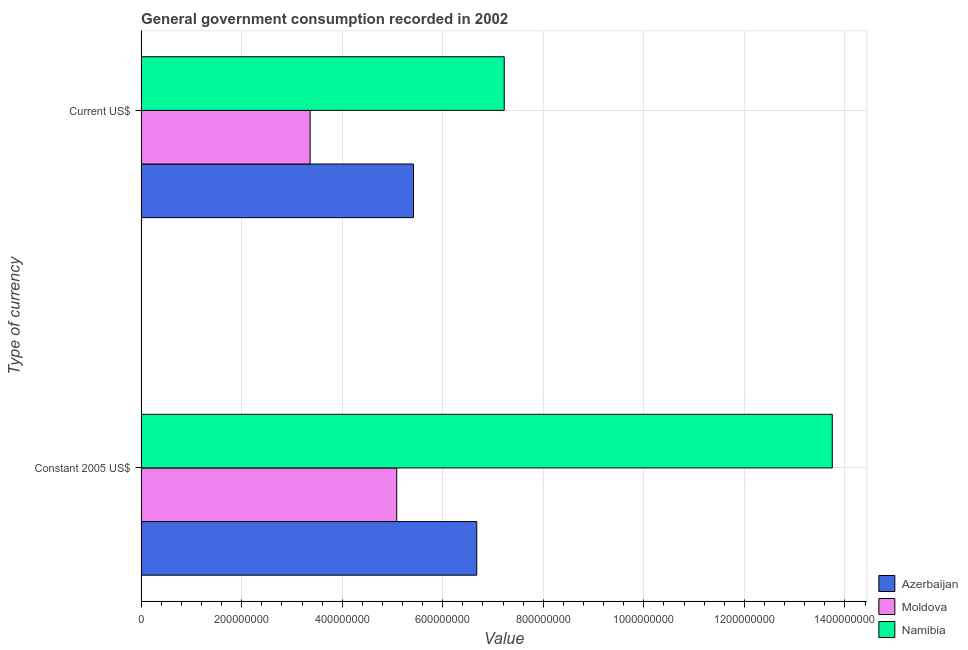How many different coloured bars are there?
Give a very brief answer. 3. Are the number of bars per tick equal to the number of legend labels?
Make the answer very short. Yes. Are the number of bars on each tick of the Y-axis equal?
Ensure brevity in your answer.  Yes. What is the label of the 1st group of bars from the top?
Offer a terse response. Current US$. What is the value consumed in constant 2005 us$ in Moldova?
Provide a succinct answer. 5.08e+08. Across all countries, what is the maximum value consumed in current us$?
Provide a short and direct response. 7.22e+08. Across all countries, what is the minimum value consumed in current us$?
Make the answer very short. 3.36e+08. In which country was the value consumed in constant 2005 us$ maximum?
Your answer should be very brief. Namibia. In which country was the value consumed in current us$ minimum?
Give a very brief answer. Moldova. What is the total value consumed in current us$ in the graph?
Your answer should be compact. 1.60e+09. What is the difference between the value consumed in constant 2005 us$ in Moldova and that in Namibia?
Make the answer very short. -8.66e+08. What is the difference between the value consumed in constant 2005 us$ in Moldova and the value consumed in current us$ in Namibia?
Offer a very short reply. -2.14e+08. What is the average value consumed in constant 2005 us$ per country?
Your response must be concise. 8.50e+08. What is the difference between the value consumed in constant 2005 us$ and value consumed in current us$ in Azerbaijan?
Your answer should be compact. 1.26e+08. What is the ratio of the value consumed in current us$ in Namibia to that in Moldova?
Offer a terse response. 2.15. In how many countries, is the value consumed in current us$ greater than the average value consumed in current us$ taken over all countries?
Make the answer very short. 2. What does the 2nd bar from the top in Constant 2005 US$ represents?
Provide a short and direct response. Moldova. What does the 1st bar from the bottom in Current US$ represents?
Ensure brevity in your answer.  Azerbaijan. Are all the bars in the graph horizontal?
Keep it short and to the point. Yes. How many countries are there in the graph?
Offer a terse response. 3. Are the values on the major ticks of X-axis written in scientific E-notation?
Your response must be concise. No. Where does the legend appear in the graph?
Provide a short and direct response. Bottom right. How many legend labels are there?
Offer a terse response. 3. How are the legend labels stacked?
Provide a succinct answer. Vertical. What is the title of the graph?
Give a very brief answer. General government consumption recorded in 2002. What is the label or title of the X-axis?
Keep it short and to the point. Value. What is the label or title of the Y-axis?
Your answer should be compact. Type of currency. What is the Value in Azerbaijan in Constant 2005 US$?
Offer a terse response. 6.68e+08. What is the Value in Moldova in Constant 2005 US$?
Offer a very short reply. 5.08e+08. What is the Value in Namibia in Constant 2005 US$?
Ensure brevity in your answer.  1.37e+09. What is the Value in Azerbaijan in Current US$?
Provide a succinct answer. 5.42e+08. What is the Value in Moldova in Current US$?
Keep it short and to the point. 3.36e+08. What is the Value in Namibia in Current US$?
Make the answer very short. 7.22e+08. Across all Type of currency, what is the maximum Value in Azerbaijan?
Your response must be concise. 6.68e+08. Across all Type of currency, what is the maximum Value of Moldova?
Offer a terse response. 5.08e+08. Across all Type of currency, what is the maximum Value in Namibia?
Your answer should be very brief. 1.37e+09. Across all Type of currency, what is the minimum Value of Azerbaijan?
Keep it short and to the point. 5.42e+08. Across all Type of currency, what is the minimum Value in Moldova?
Give a very brief answer. 3.36e+08. Across all Type of currency, what is the minimum Value of Namibia?
Your answer should be compact. 7.22e+08. What is the total Value of Azerbaijan in the graph?
Offer a very short reply. 1.21e+09. What is the total Value in Moldova in the graph?
Your answer should be compact. 8.45e+08. What is the total Value in Namibia in the graph?
Your response must be concise. 2.10e+09. What is the difference between the Value of Azerbaijan in Constant 2005 US$ and that in Current US$?
Your response must be concise. 1.26e+08. What is the difference between the Value in Moldova in Constant 2005 US$ and that in Current US$?
Provide a succinct answer. 1.72e+08. What is the difference between the Value of Namibia in Constant 2005 US$ and that in Current US$?
Offer a terse response. 6.53e+08. What is the difference between the Value in Azerbaijan in Constant 2005 US$ and the Value in Moldova in Current US$?
Keep it short and to the point. 3.32e+08. What is the difference between the Value in Azerbaijan in Constant 2005 US$ and the Value in Namibia in Current US$?
Offer a very short reply. -5.46e+07. What is the difference between the Value of Moldova in Constant 2005 US$ and the Value of Namibia in Current US$?
Make the answer very short. -2.14e+08. What is the average Value in Azerbaijan per Type of currency?
Make the answer very short. 6.05e+08. What is the average Value in Moldova per Type of currency?
Your answer should be very brief. 4.22e+08. What is the average Value in Namibia per Type of currency?
Provide a succinct answer. 1.05e+09. What is the difference between the Value in Azerbaijan and Value in Moldova in Constant 2005 US$?
Provide a short and direct response. 1.59e+08. What is the difference between the Value in Azerbaijan and Value in Namibia in Constant 2005 US$?
Provide a succinct answer. -7.07e+08. What is the difference between the Value in Moldova and Value in Namibia in Constant 2005 US$?
Offer a terse response. -8.66e+08. What is the difference between the Value of Azerbaijan and Value of Moldova in Current US$?
Offer a terse response. 2.06e+08. What is the difference between the Value in Azerbaijan and Value in Namibia in Current US$?
Your answer should be compact. -1.81e+08. What is the difference between the Value in Moldova and Value in Namibia in Current US$?
Provide a succinct answer. -3.86e+08. What is the ratio of the Value in Azerbaijan in Constant 2005 US$ to that in Current US$?
Provide a short and direct response. 1.23. What is the ratio of the Value of Moldova in Constant 2005 US$ to that in Current US$?
Your answer should be compact. 1.51. What is the ratio of the Value of Namibia in Constant 2005 US$ to that in Current US$?
Your response must be concise. 1.9. What is the difference between the highest and the second highest Value of Azerbaijan?
Offer a terse response. 1.26e+08. What is the difference between the highest and the second highest Value of Moldova?
Offer a terse response. 1.72e+08. What is the difference between the highest and the second highest Value of Namibia?
Offer a terse response. 6.53e+08. What is the difference between the highest and the lowest Value of Azerbaijan?
Your answer should be very brief. 1.26e+08. What is the difference between the highest and the lowest Value of Moldova?
Your answer should be compact. 1.72e+08. What is the difference between the highest and the lowest Value in Namibia?
Offer a terse response. 6.53e+08. 